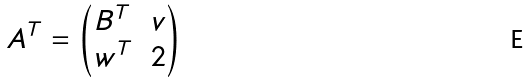<formula> <loc_0><loc_0><loc_500><loc_500>A ^ { T } = \begin{pmatrix} B ^ { T } & v \\ w ^ { T } & 2 \end{pmatrix}</formula> 